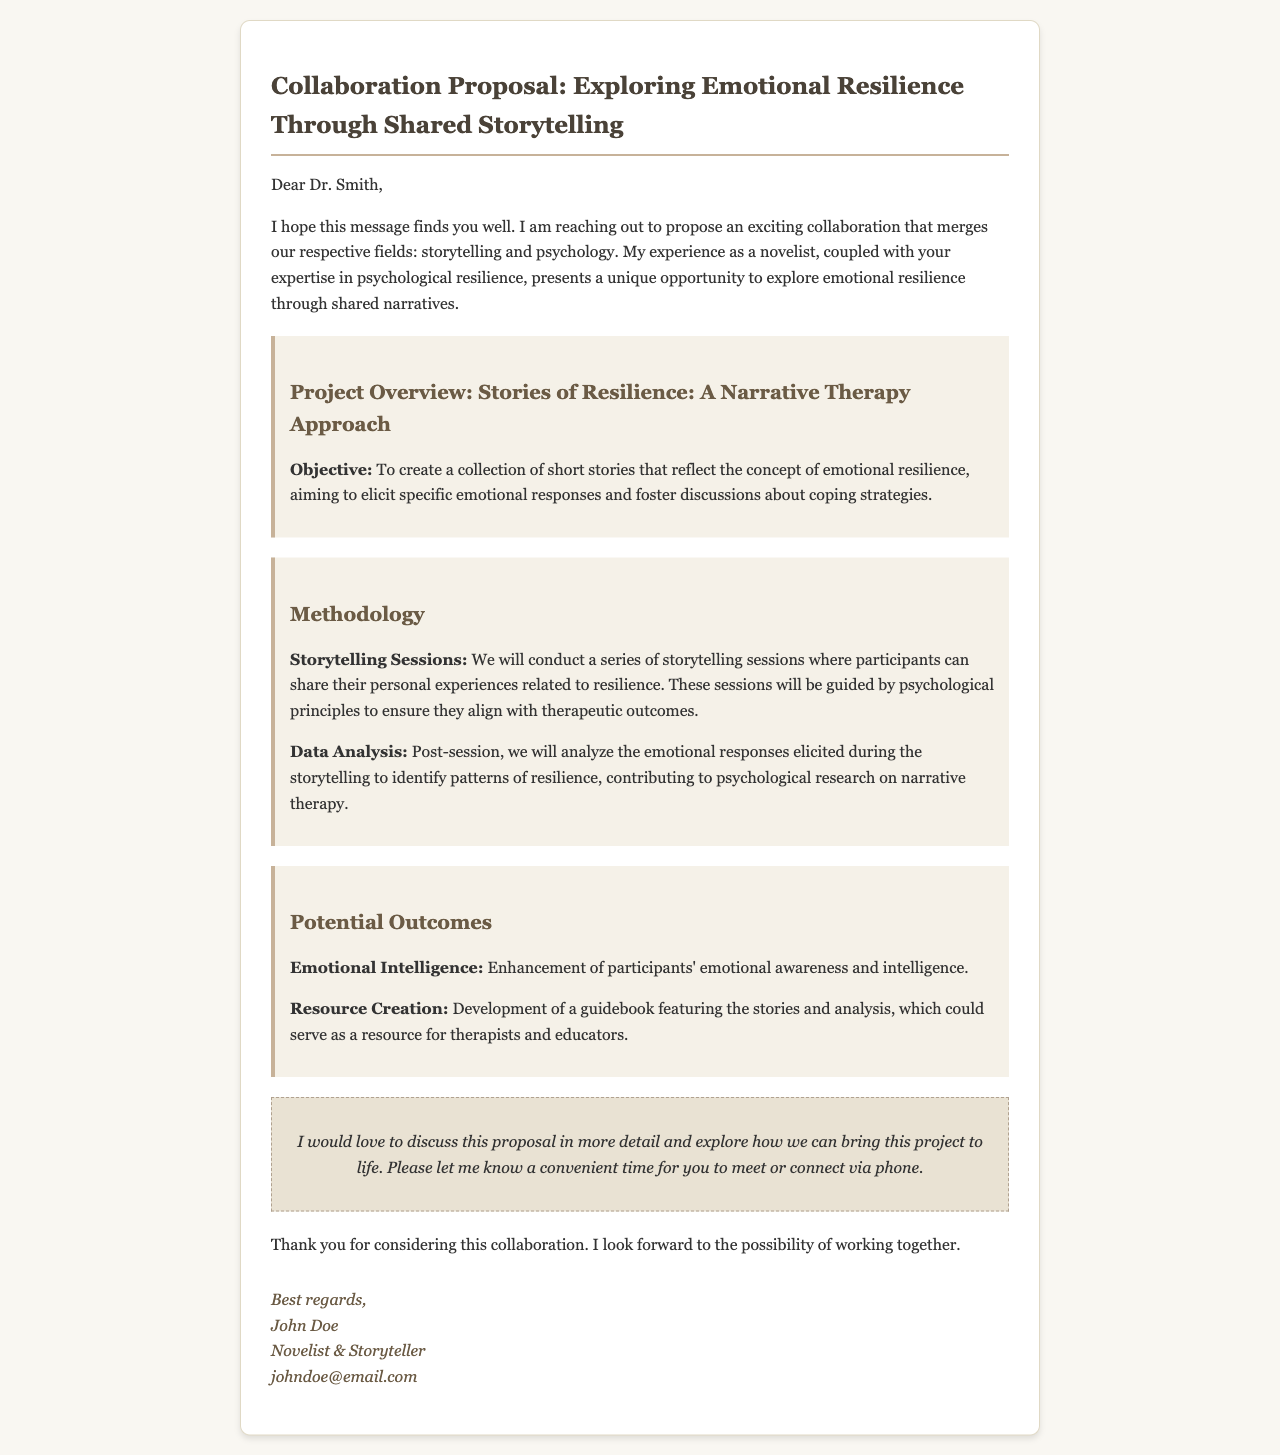What is the title of the collaboration proposal? The title is clearly stated at the beginning of the document, which is "Collaboration Proposal: Exploring Emotional Resilience Through Shared Storytelling."
Answer: Collaboration Proposal: Exploring Emotional Resilience Through Shared Storytelling Who is the email addressed to? The recipient of the email is mentioned in the greeting, which indicates that the email is addressed to Dr. Smith.
Answer: Dr. Smith What is the main objective of the project? The objective is outlined in the project overview section, highlighting the aim to create a collection of short stories reflecting emotional resilience.
Answer: To create a collection of short stories that reflect the concept of emotional resilience What are the two main components of the methodology? The methodology section lists specific actions, including storytelling sessions and data analysis.
Answer: Storytelling Sessions, Data Analysis What potential outcome focuses on improving participants' awareness? The potential outcomes section includes information about enhancing emotional intelligence related to the participants.
Answer: Enhancement of participants' emotional awareness and intelligence 